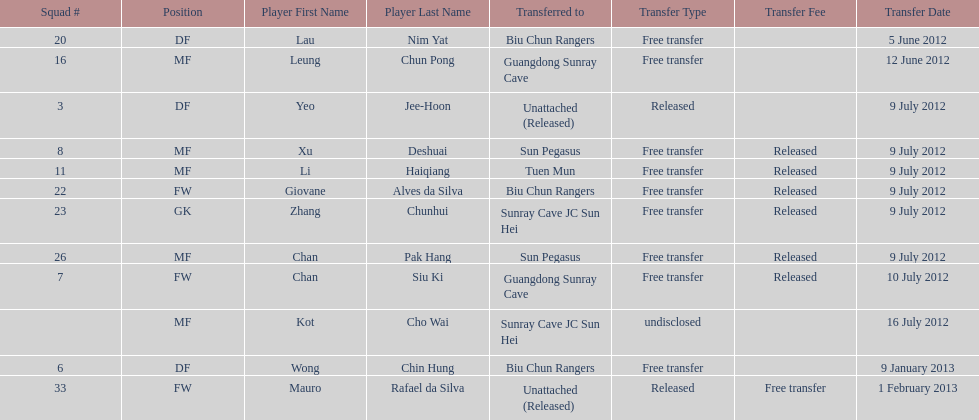What is the total number of players listed? 12. 